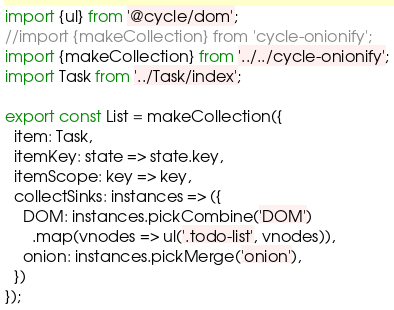<code> <loc_0><loc_0><loc_500><loc_500><_JavaScript_>import {ul} from '@cycle/dom';
//import {makeCollection} from 'cycle-onionify';
import {makeCollection} from '../../cycle-onionify';
import Task from '../Task/index';

export const List = makeCollection({
  item: Task,
  itemKey: state => state.key,
  itemScope: key => key,
  collectSinks: instances => ({
    DOM: instances.pickCombine('DOM')
      .map(vnodes => ul('.todo-list', vnodes)),
    onion: instances.pickMerge('onion'),
  })
});
</code> 